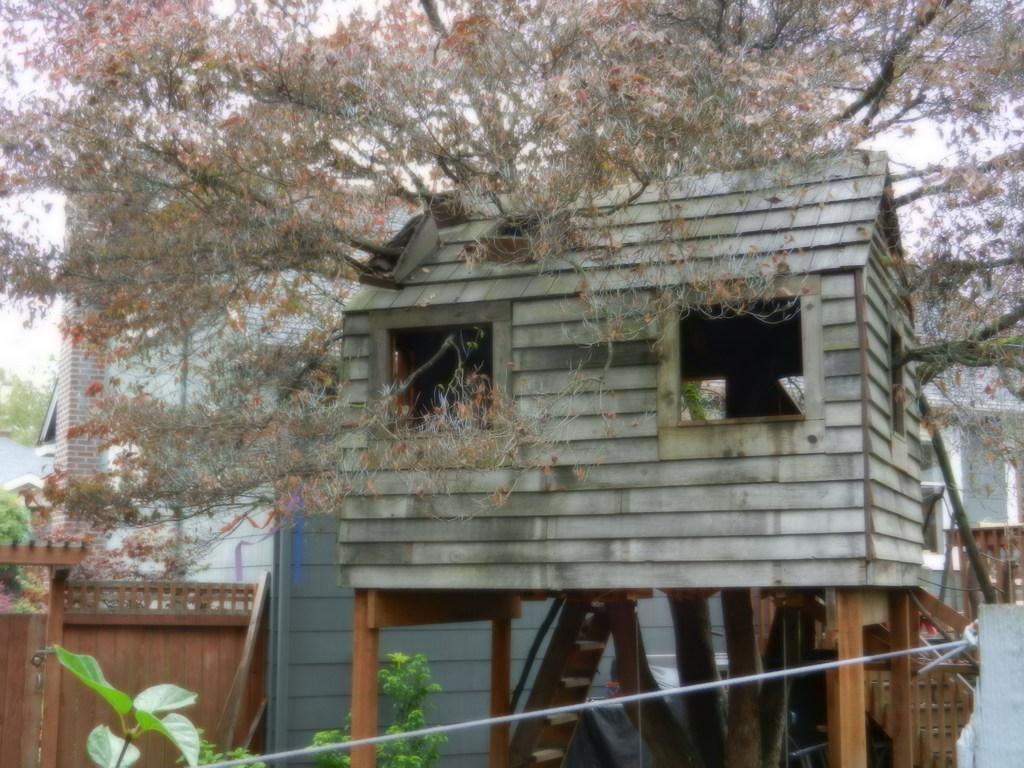Please provide a concise description of this image. In this image there is a wooden house on the pillars. Few branches of a tree are coming out of the windows of the house. Left bottom there is a wall. Before it there are few plants having leaves. Background there are buildings and trees. Behind there is sky. 